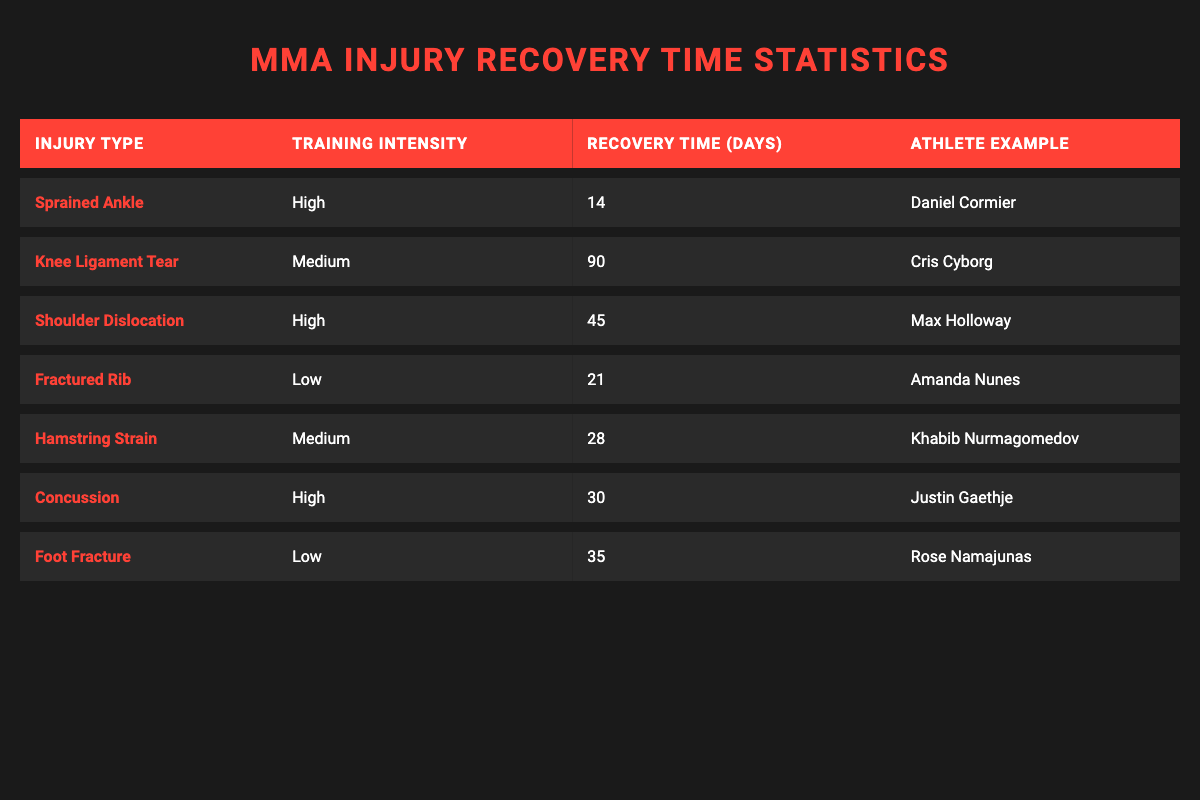What is the recovery time for a sprained ankle? The table shows the recovery time for a sprained ankle listed as 14 days.
Answer: 14 days Who is the athlete example for a knee ligament tear? The table specifies Cris Cyborg as the athlete example for a knee ligament tear.
Answer: Cris Cyborg Which injury takes the longest to recover from according to the table? The knee ligament tear has the longest recovery time of 90 days compared to the other injuries listed.
Answer: Knee ligament tear Is the recovery time for a concussion longer than for a fractured rib? The recovery time for a concussion is 30 days, while a fractured rib takes 21 days, so the concussion does not have a longer recovery time.
Answer: No What is the average recovery time for injuries with high training intensity? The high training intensity injuries are a sprained ankle (14 days), shoulder dislocation (45 days), and concussion (30 days). Summing these gives 14 + 45 + 30 = 89 days. There are three injuries, so the average is 89 / 3 = 29.67, which rounds to approximately 30 days.
Answer: 30 days Which injuries listed have a recovery time shorter than 30 days? The sprained ankle (14 days) and the concussion (30 days) have recovery times of 30 days or less; thus, only the sprained ankle is shorter than 30 days.
Answer: Sprained ankle How does the recovery time for a hamstring strain compare to that of a fractured rib? The recovery time for a hamstring strain is 28 days, while the fractured rib takes 21 days. Therefore, the hamstring strain requires 7 more days for recovery than the fractured rib.
Answer: 7 days longer Are there any injuries in the table that have a recovery time of 35 days or more? Yes, the knee ligament tear (90 days), foot fracture (35 days), and shoulder dislocation (45 days) have recovery times of 35 days or more, so there are injuries that fit this criterion.
Answer: Yes What is the total recovery time for all injuries in the table? The total recovery time is calculated by summing all recovery times: 14 + 90 + 45 + 21 + 28 + 30 + 35 = 263 days. Therefore, the total recovery time is 263 days.
Answer: 263 days 